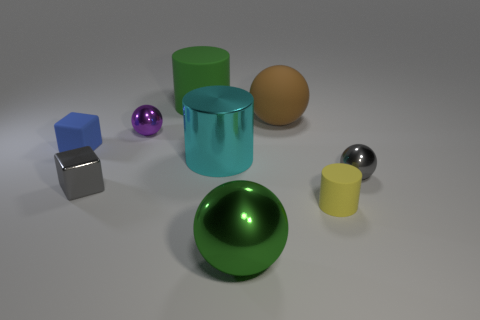Add 1 small cyan objects. How many objects exist? 10 Subtract all big metal spheres. How many spheres are left? 3 Subtract all blue blocks. How many blocks are left? 1 Subtract all cylinders. How many objects are left? 6 Subtract all purple cylinders. How many yellow balls are left? 0 Subtract all tiny yellow rubber blocks. Subtract all purple spheres. How many objects are left? 8 Add 3 purple things. How many purple things are left? 4 Add 4 big matte objects. How many big matte objects exist? 6 Subtract 0 cyan cubes. How many objects are left? 9 Subtract all green spheres. Subtract all cyan cylinders. How many spheres are left? 3 